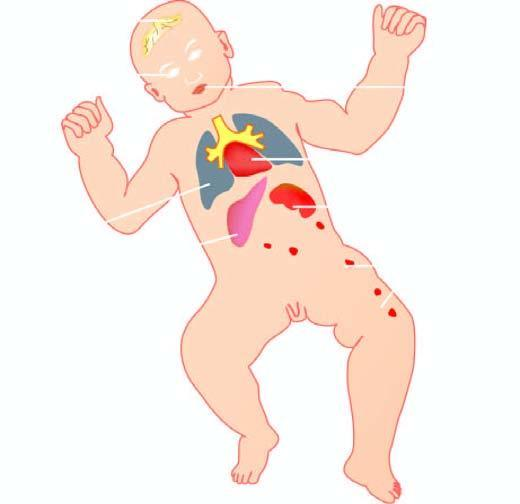s a giant cell with inclusions produced by torch complex infection in foetus in utero?
Answer the question using a single word or phrase. No 